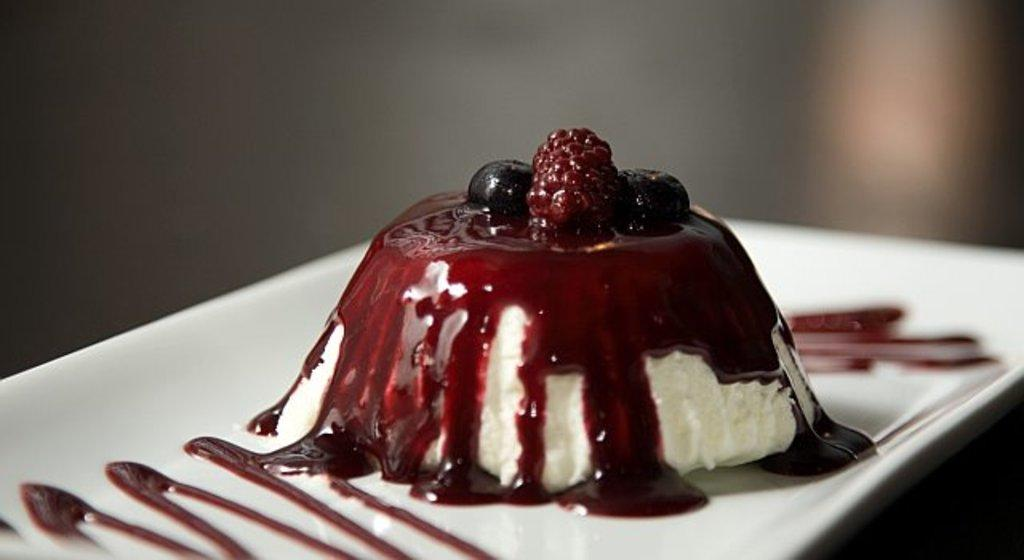What is on the plate that is visible in the image? There is food on a plate in the image. Can you describe the background of the image? The background of the image is blurry. What type of guide is present in the image to help with the food preparation? There is no guide present in the image; it only shows food on a plate and a blurry background. 